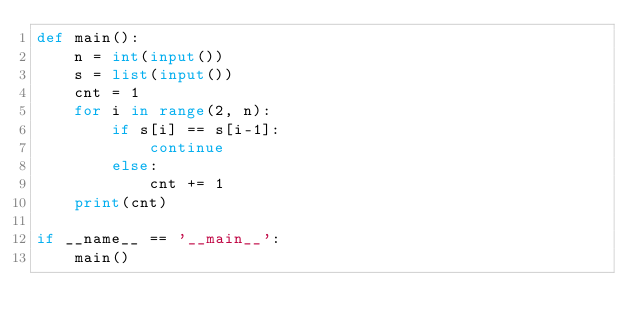<code> <loc_0><loc_0><loc_500><loc_500><_Python_>def main():
    n = int(input())
    s = list(input())
    cnt = 1
    for i in range(2, n):
        if s[i] == s[i-1]:
            continue
        else:
            cnt += 1
    print(cnt)

if __name__ == '__main__':
    main()</code> 